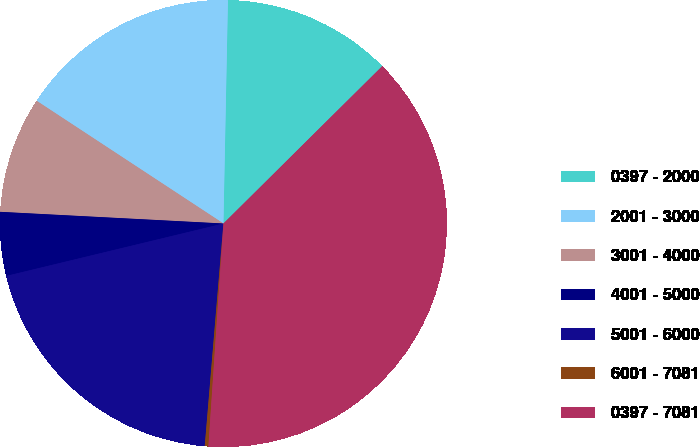Convert chart to OTSL. <chart><loc_0><loc_0><loc_500><loc_500><pie_chart><fcel>0397 - 2000<fcel>2001 - 3000<fcel>3001 - 4000<fcel>4001 - 5000<fcel>5001 - 6000<fcel>6001 - 7081<fcel>0397 - 7081<nl><fcel>12.25%<fcel>16.07%<fcel>8.42%<fcel>4.6%<fcel>19.9%<fcel>0.26%<fcel>38.5%<nl></chart> 